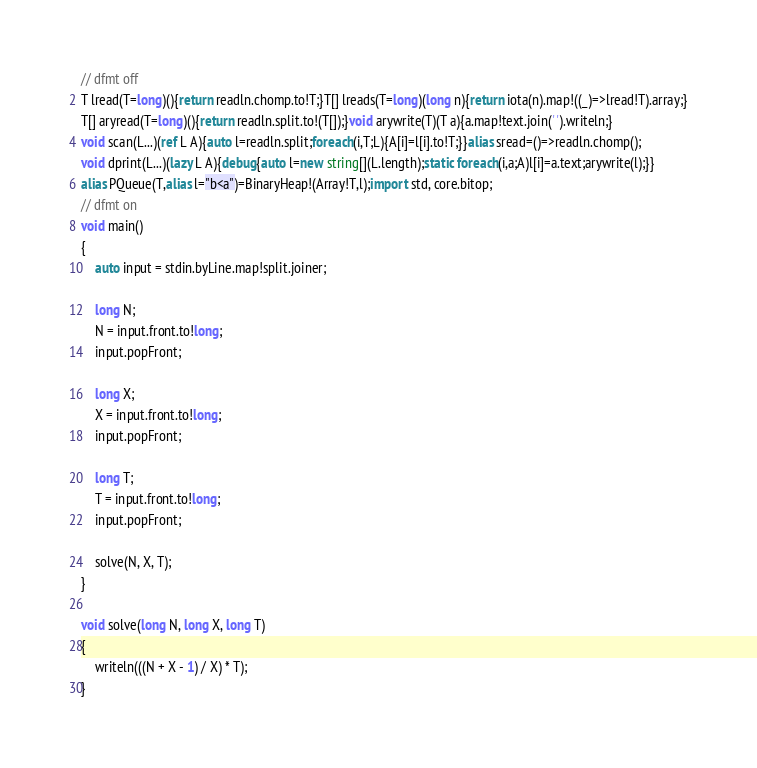<code> <loc_0><loc_0><loc_500><loc_500><_D_>// dfmt off
T lread(T=long)(){return readln.chomp.to!T;}T[] lreads(T=long)(long n){return iota(n).map!((_)=>lread!T).array;}
T[] aryread(T=long)(){return readln.split.to!(T[]);}void arywrite(T)(T a){a.map!text.join(' ').writeln;}
void scan(L...)(ref L A){auto l=readln.split;foreach(i,T;L){A[i]=l[i].to!T;}}alias sread=()=>readln.chomp();
void dprint(L...)(lazy L A){debug{auto l=new string[](L.length);static foreach(i,a;A)l[i]=a.text;arywrite(l);}}
alias PQueue(T,alias l="b<a")=BinaryHeap!(Array!T,l);import std, core.bitop;
// dfmt on
void main()
{
    auto input = stdin.byLine.map!split.joiner;

    long N;
    N = input.front.to!long;
    input.popFront;

    long X;
    X = input.front.to!long;
    input.popFront;

    long T;
    T = input.front.to!long;
    input.popFront;

    solve(N, X, T);
}

void solve(long N, long X, long T)
{
    writeln(((N + X - 1) / X) * T);
}
</code> 